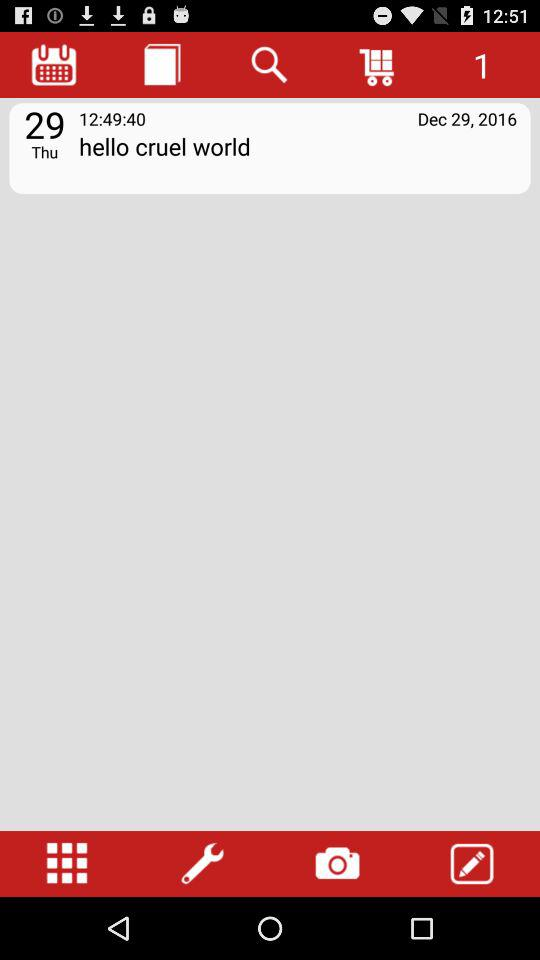What is the given time? The given time is 12:49:40. 